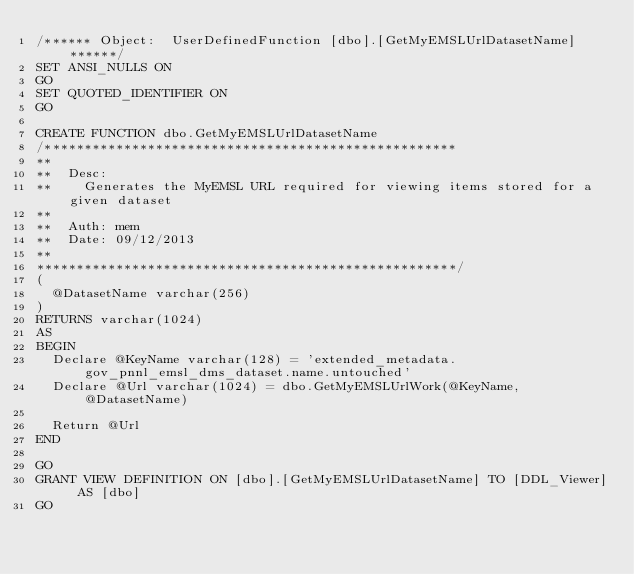<code> <loc_0><loc_0><loc_500><loc_500><_SQL_>/****** Object:  UserDefinedFunction [dbo].[GetMyEMSLUrlDatasetName] ******/
SET ANSI_NULLS ON
GO
SET QUOTED_IDENTIFIER ON
GO

CREATE FUNCTION dbo.GetMyEMSLUrlDatasetName
/****************************************************
**
**	Desc: 
**		Generates the MyEMSL URL required for viewing items stored for a given dataset
**
**	Auth:	mem
**	Date:	09/12/2013
**    
*****************************************************/
(
	@DatasetName varchar(256)
)
RETURNS varchar(1024)
AS
BEGIN
	Declare @KeyName varchar(128) = 'extended_metadata.gov_pnnl_emsl_dms_dataset.name.untouched'
	Declare @Url varchar(1024) = dbo.GetMyEMSLUrlWork(@KeyName, @DatasetName)
	
	Return @Url
END

GO
GRANT VIEW DEFINITION ON [dbo].[GetMyEMSLUrlDatasetName] TO [DDL_Viewer] AS [dbo]
GO
</code> 